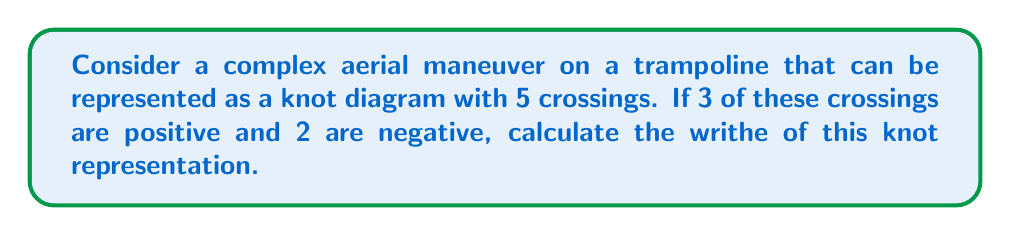Provide a solution to this math problem. To solve this problem, let's follow these steps:

1. Understand the concept of writhe:
   The writhe of a knot diagram is the sum of the signs of all crossings in the diagram.

2. Identify the crossing signs:
   - Positive crossings: 3
   - Negative crossings: 2

3. Calculate the writhe:
   $$\text{Writhe} = \text{Number of positive crossings} - \text{Number of negative crossings}$$
   
   Substituting the values:
   $$\text{Writhe} = 3 - 2$$

4. Perform the calculation:
   $$\text{Writhe} = 1$$

The writhe of this knot representation of the complex aerial maneuver is 1.

Note: In the context of trampoline maneuvers, the writhe can be interpreted as a measure of the overall twisting nature of the move. A positive writhe indicates a predominance of right-handed twists, while a negative writhe would indicate more left-handed twists.
Answer: 1 